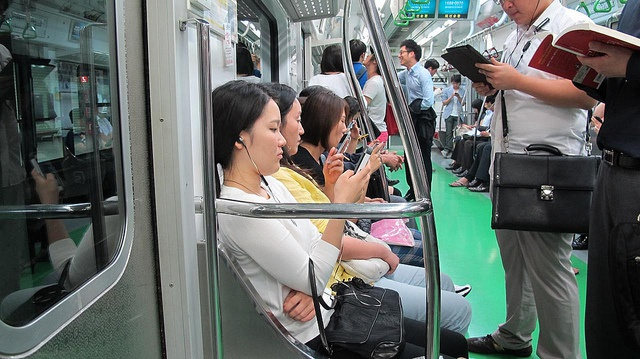Describe the objects in this image and their specific colors. I can see people in black, lightgray, darkgray, and gray tones, people in black, gray, darkgray, and lightgray tones, people in black, gray, maroon, and brown tones, handbag in black, gray, and darkgray tones, and people in black, lightpink, gray, and darkgray tones in this image. 